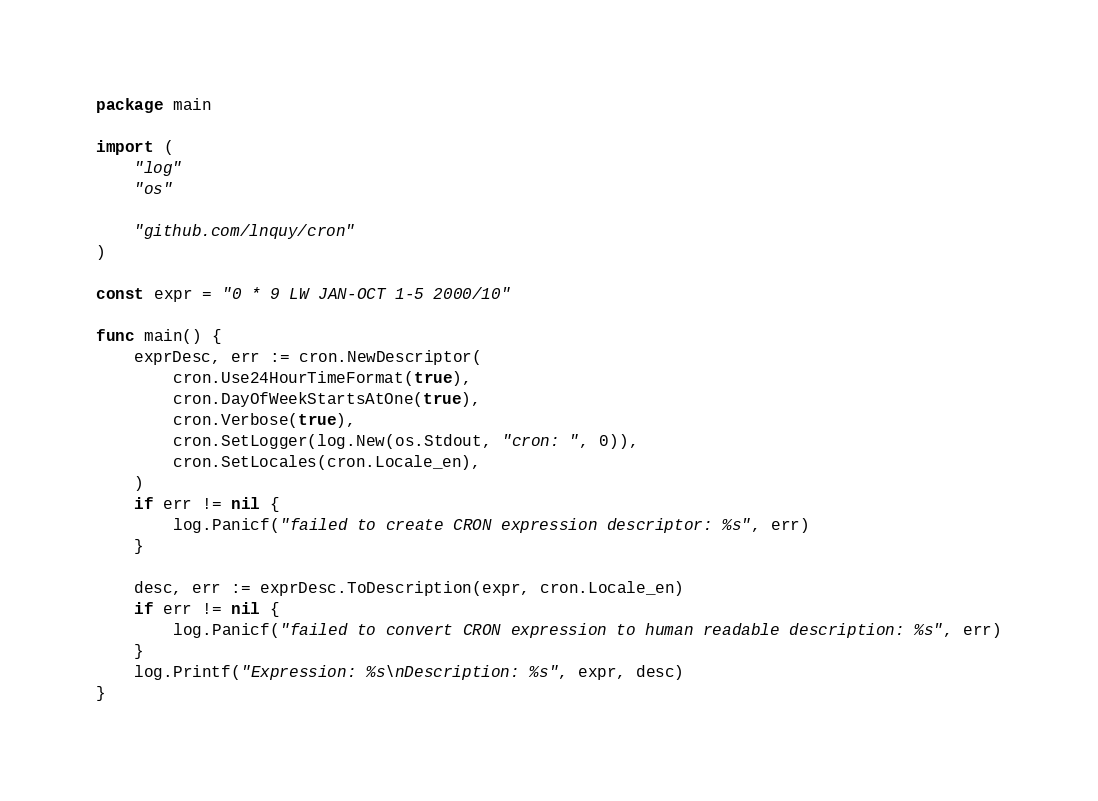Convert code to text. <code><loc_0><loc_0><loc_500><loc_500><_Go_>package main

import (
	"log"
	"os"

	"github.com/lnquy/cron"
)

const expr = "0 * 9 LW JAN-OCT 1-5 2000/10"

func main() {
	exprDesc, err := cron.NewDescriptor(
		cron.Use24HourTimeFormat(true),
		cron.DayOfWeekStartsAtOne(true),
		cron.Verbose(true),
		cron.SetLogger(log.New(os.Stdout, "cron: ", 0)),
		cron.SetLocales(cron.Locale_en),
	)
	if err != nil {
		log.Panicf("failed to create CRON expression descriptor: %s", err)
	}

	desc, err := exprDesc.ToDescription(expr, cron.Locale_en)
	if err != nil {
		log.Panicf("failed to convert CRON expression to human readable description: %s", err)
	}
	log.Printf("Expression: %s\nDescription: %s", expr, desc)
}
</code> 